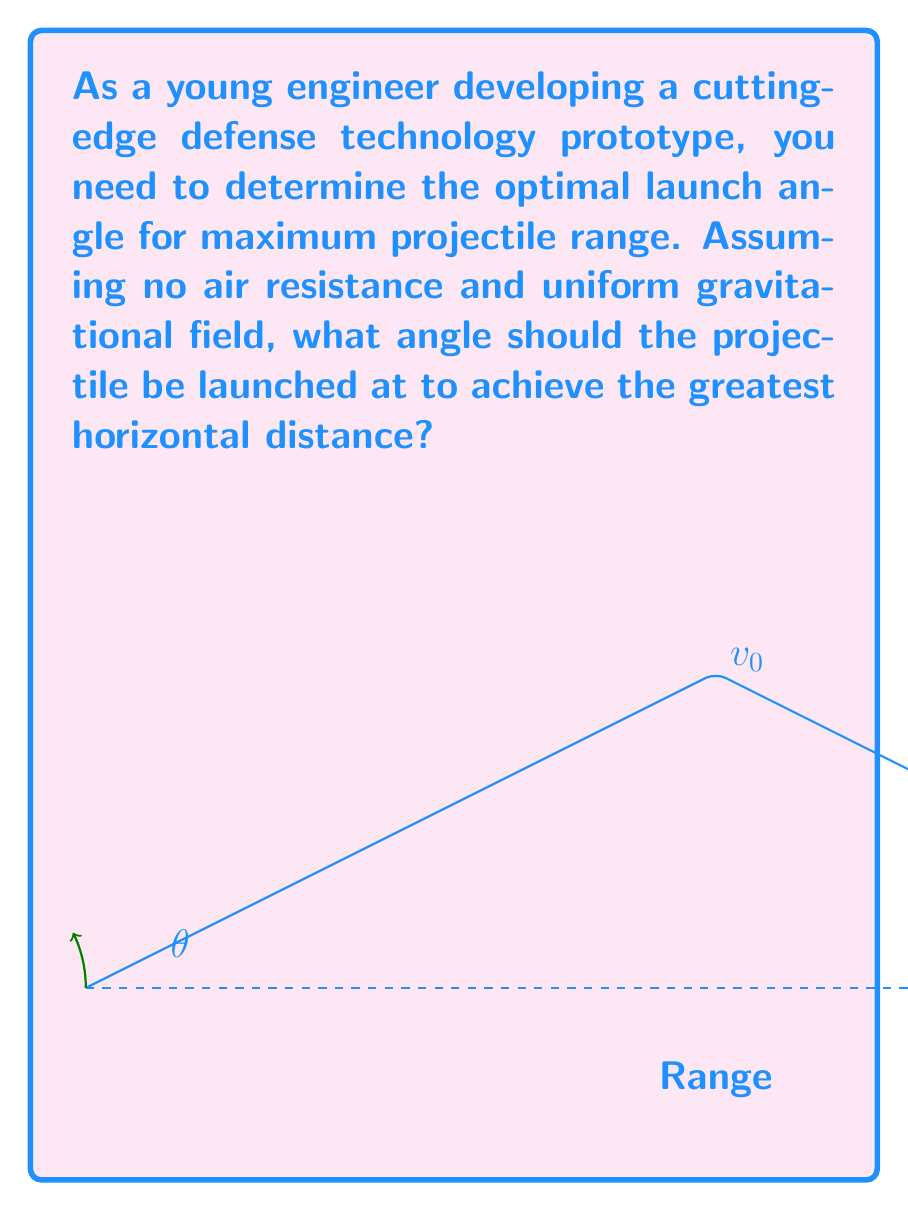Could you help me with this problem? To solve this problem, we need to use the principles of projectile motion. Let's break it down step-by-step:

1) In projectile motion, the range $R$ is given by the equation:

   $$R = \frac{v_0^2 \sin(2\theta)}{g}$$

   Where $v_0$ is the initial velocity, $\theta$ is the launch angle, and $g$ is the acceleration due to gravity.

2) To find the maximum range, we need to maximize $\sin(2\theta)$.

3) The sine function reaches its maximum value of 1 when its argument is 90°.

4) So, we want:

   $$2\theta = 90°$$

5) Solving for $\theta$:

   $$\theta = 45°$$

6) This result is independent of the initial velocity and the gravitational acceleration, making it universally applicable for projectile motion in a uniform gravitational field without air resistance.

7) Physically, this angle provides an optimal balance between the horizontal and vertical components of the initial velocity, maximizing the time of flight while maintaining sufficient horizontal motion.
Answer: $45°$ 